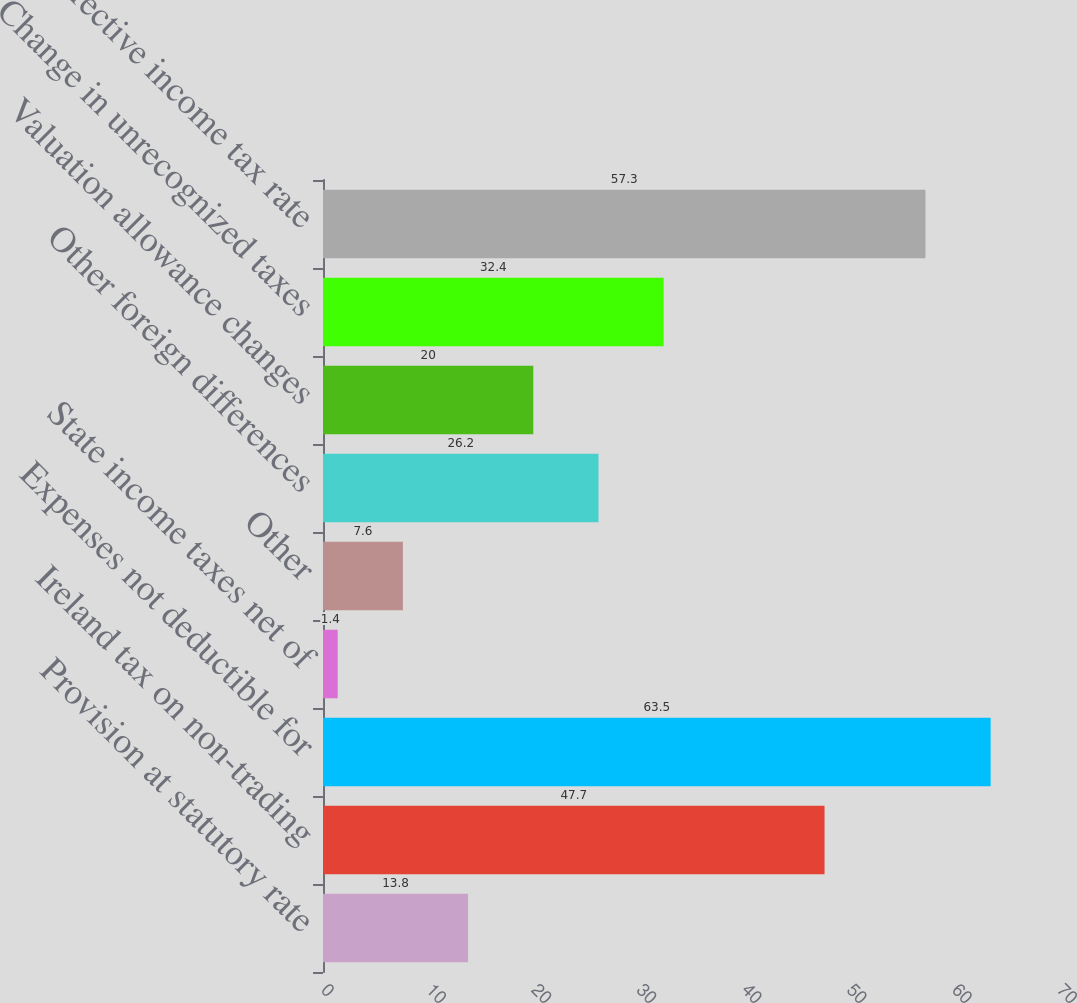Convert chart to OTSL. <chart><loc_0><loc_0><loc_500><loc_500><bar_chart><fcel>Provision at statutory rate<fcel>Ireland tax on non-trading<fcel>Expenses not deductible for<fcel>State income taxes net of<fcel>Other<fcel>Other foreign differences<fcel>Valuation allowance changes<fcel>Change in unrecognized taxes<fcel>Effective income tax rate<nl><fcel>13.8<fcel>47.7<fcel>63.5<fcel>1.4<fcel>7.6<fcel>26.2<fcel>20<fcel>32.4<fcel>57.3<nl></chart> 